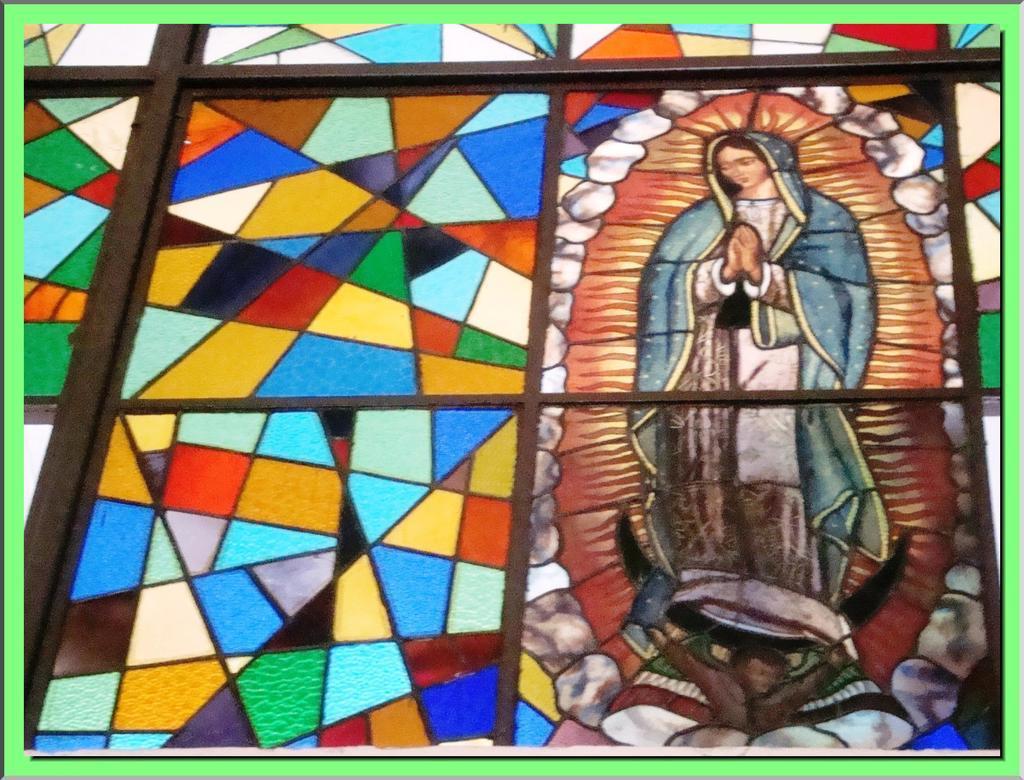In one or two sentences, can you explain what this image depicts? In this image we can see ,there are windows covered with irons and also on the right side there is a poster of a god. 